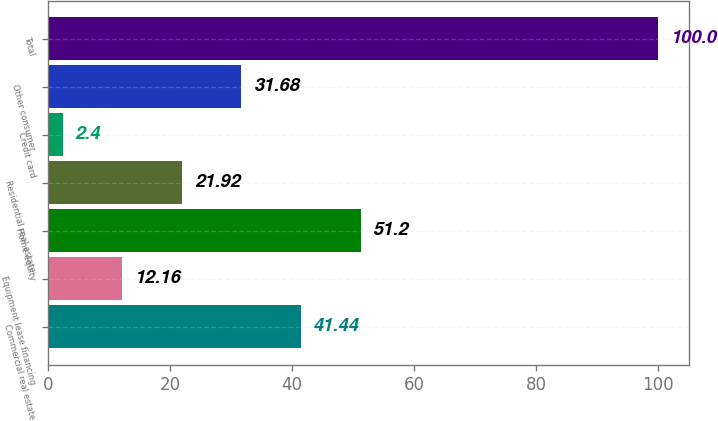<chart> <loc_0><loc_0><loc_500><loc_500><bar_chart><fcel>Commercial real estate<fcel>Equipment lease financing<fcel>Home equity<fcel>Residential real estate<fcel>Credit card<fcel>Other consumer<fcel>Total<nl><fcel>41.44<fcel>12.16<fcel>51.2<fcel>21.92<fcel>2.4<fcel>31.68<fcel>100<nl></chart> 